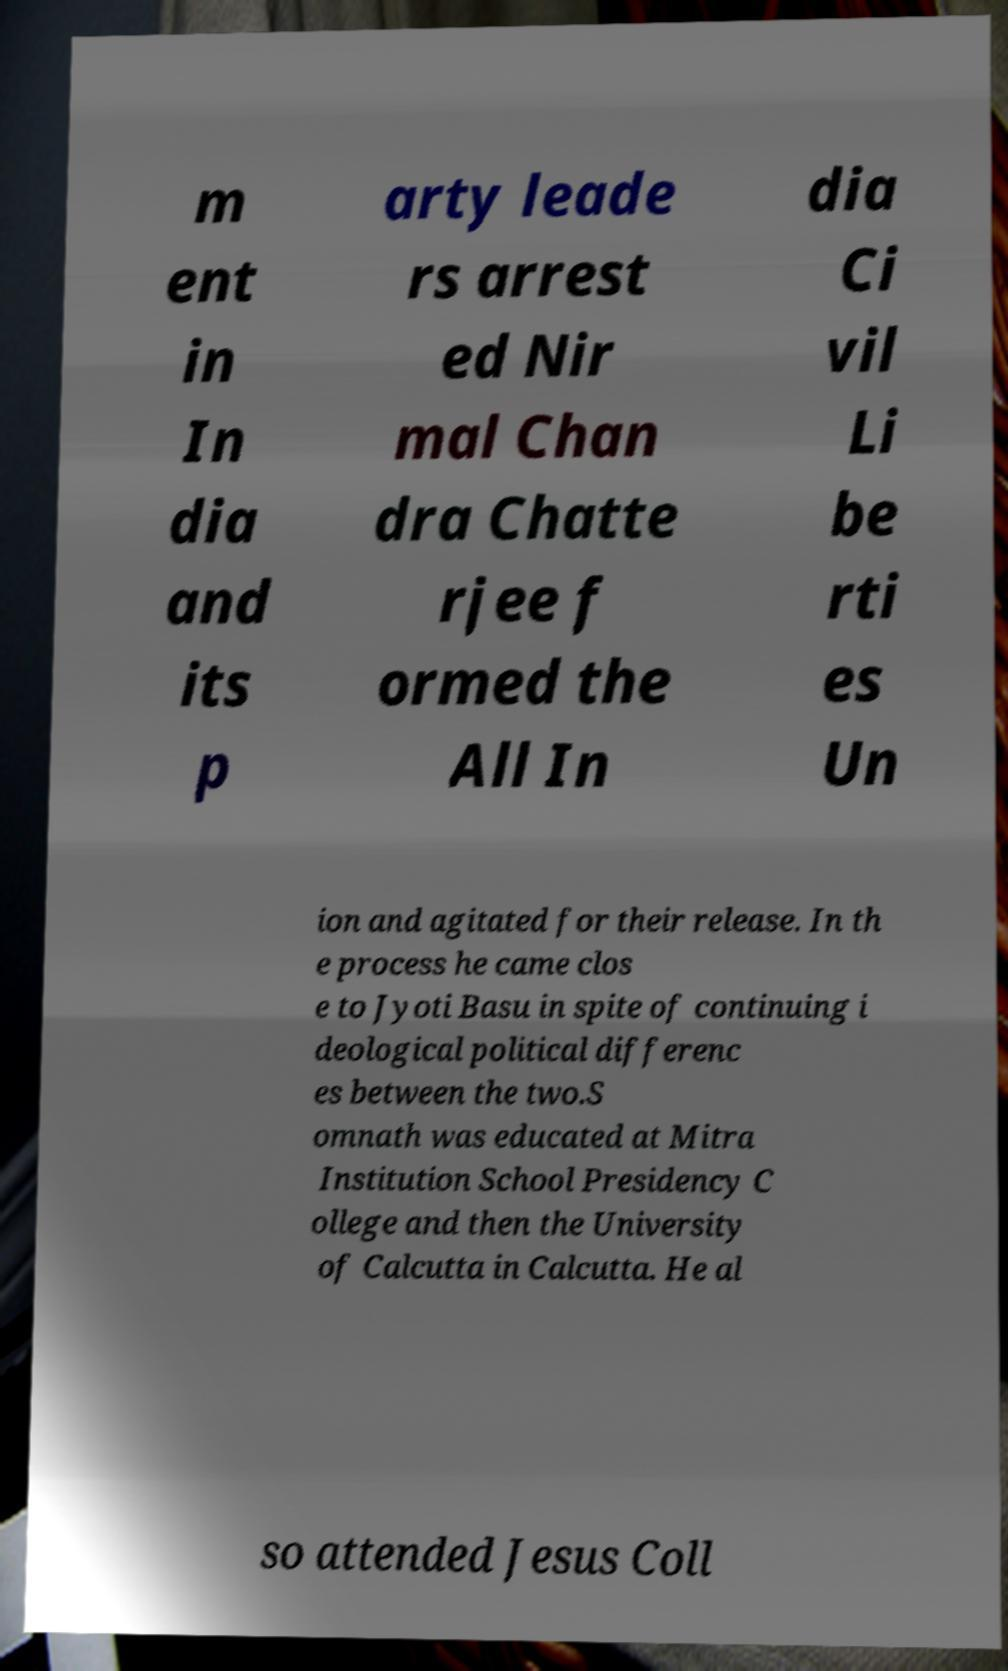I need the written content from this picture converted into text. Can you do that? m ent in In dia and its p arty leade rs arrest ed Nir mal Chan dra Chatte rjee f ormed the All In dia Ci vil Li be rti es Un ion and agitated for their release. In th e process he came clos e to Jyoti Basu in spite of continuing i deological political differenc es between the two.S omnath was educated at Mitra Institution School Presidency C ollege and then the University of Calcutta in Calcutta. He al so attended Jesus Coll 